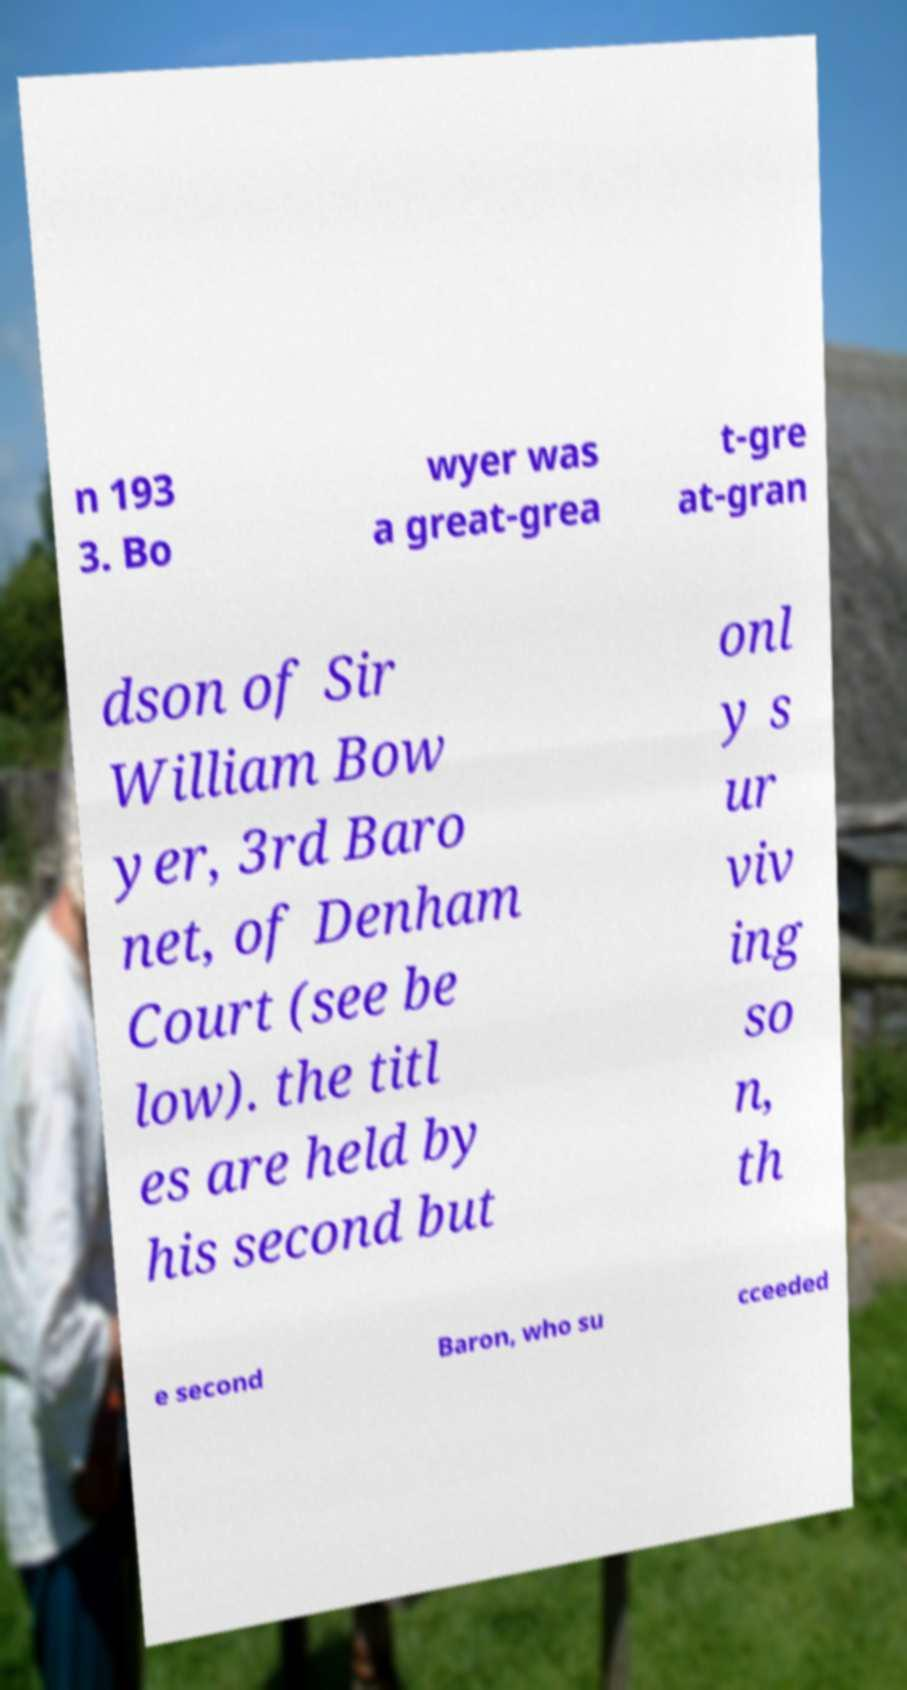Could you assist in decoding the text presented in this image and type it out clearly? n 193 3. Bo wyer was a great-grea t-gre at-gran dson of Sir William Bow yer, 3rd Baro net, of Denham Court (see be low). the titl es are held by his second but onl y s ur viv ing so n, th e second Baron, who su cceeded 